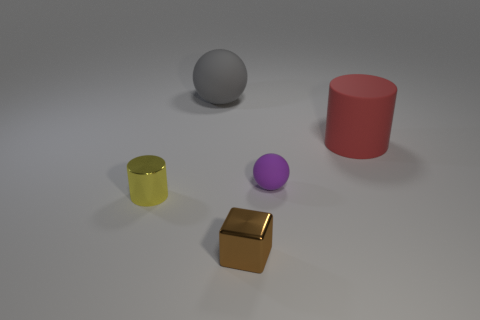What color is the small shiny object that is to the right of the small yellow shiny cylinder?
Keep it short and to the point. Brown. There is a sphere to the left of the tiny shiny object that is in front of the small yellow shiny object; are there any matte spheres behind it?
Provide a short and direct response. No. Are there more small purple matte objects that are left of the purple sphere than shiny cylinders?
Your response must be concise. No. Is the shape of the tiny object that is right of the brown metallic block the same as  the yellow object?
Your response must be concise. No. Are there any other things that are the same material as the yellow cylinder?
Your answer should be compact. Yes. How many objects are big purple rubber cylinders or big objects to the left of the brown object?
Ensure brevity in your answer.  1. There is a rubber object that is both on the left side of the big rubber cylinder and right of the large gray thing; what is its size?
Your answer should be compact. Small. Is the number of big red matte cylinders in front of the large red matte thing greater than the number of rubber cylinders that are in front of the tiny yellow metallic cylinder?
Offer a terse response. No. There is a big red rubber object; does it have the same shape as the shiny object on the left side of the big gray sphere?
Your answer should be compact. Yes. What number of other objects are there of the same shape as the brown object?
Your answer should be very brief. 0. 